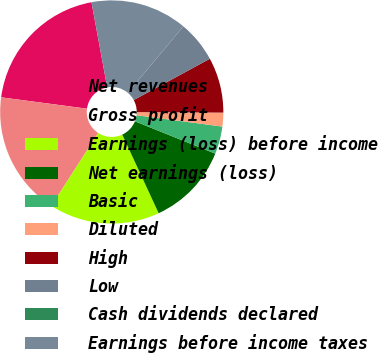<chart> <loc_0><loc_0><loc_500><loc_500><pie_chart><fcel>Net revenues<fcel>Gross profit<fcel>Earnings (loss) before income<fcel>Net earnings (loss)<fcel>Basic<fcel>Diluted<fcel>High<fcel>Low<fcel>Cash dividends declared<fcel>Earnings before income taxes<nl><fcel>20.0%<fcel>18.0%<fcel>16.0%<fcel>12.0%<fcel>4.0%<fcel>2.0%<fcel>8.0%<fcel>6.0%<fcel>0.0%<fcel>14.0%<nl></chart> 